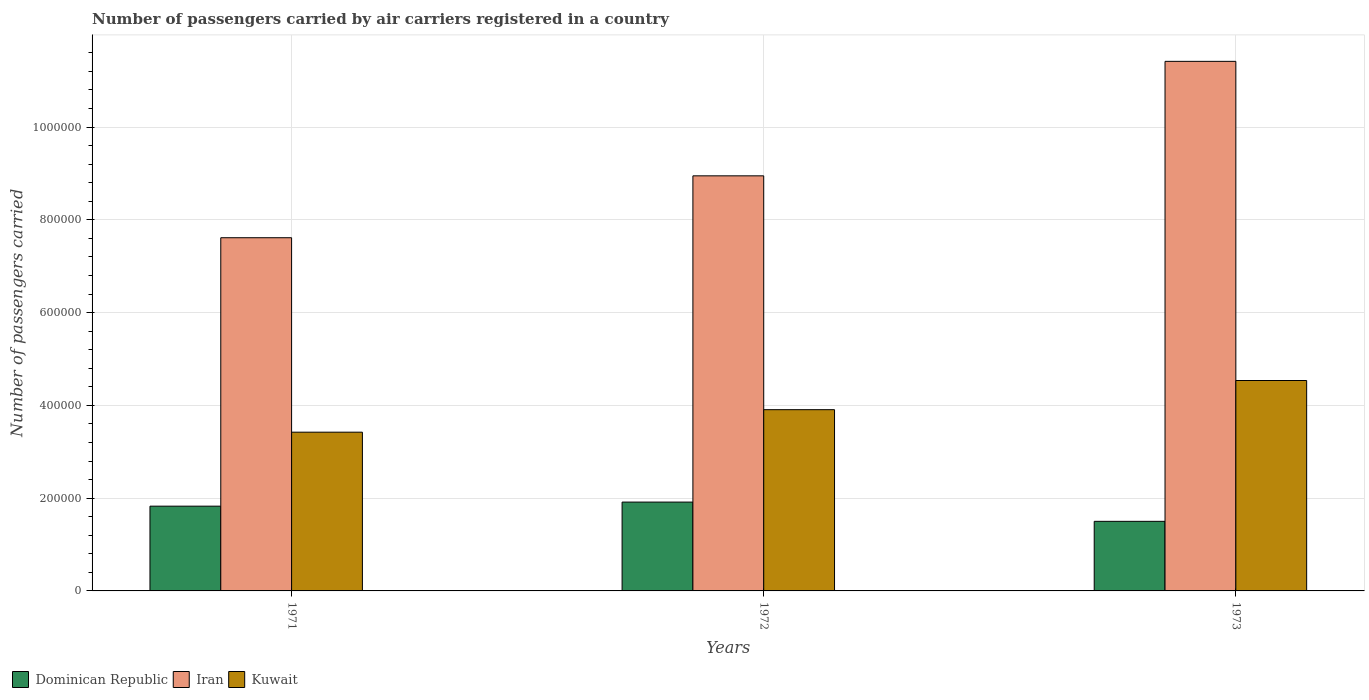How many bars are there on the 2nd tick from the left?
Your answer should be very brief. 3. How many bars are there on the 2nd tick from the right?
Provide a short and direct response. 3. What is the label of the 2nd group of bars from the left?
Give a very brief answer. 1972. In how many cases, is the number of bars for a given year not equal to the number of legend labels?
Give a very brief answer. 0. What is the number of passengers carried by air carriers in Iran in 1971?
Your response must be concise. 7.61e+05. Across all years, what is the maximum number of passengers carried by air carriers in Kuwait?
Offer a very short reply. 4.54e+05. Across all years, what is the minimum number of passengers carried by air carriers in Kuwait?
Provide a succinct answer. 3.42e+05. In which year was the number of passengers carried by air carriers in Kuwait minimum?
Ensure brevity in your answer.  1971. What is the total number of passengers carried by air carriers in Iran in the graph?
Provide a succinct answer. 2.80e+06. What is the difference between the number of passengers carried by air carriers in Kuwait in 1971 and that in 1973?
Ensure brevity in your answer.  -1.11e+05. What is the difference between the number of passengers carried by air carriers in Iran in 1973 and the number of passengers carried by air carriers in Kuwait in 1972?
Provide a succinct answer. 7.51e+05. What is the average number of passengers carried by air carriers in Iran per year?
Keep it short and to the point. 9.33e+05. In the year 1971, what is the difference between the number of passengers carried by air carriers in Iran and number of passengers carried by air carriers in Dominican Republic?
Ensure brevity in your answer.  5.79e+05. What is the ratio of the number of passengers carried by air carriers in Iran in 1971 to that in 1972?
Provide a short and direct response. 0.85. What is the difference between the highest and the second highest number of passengers carried by air carriers in Kuwait?
Keep it short and to the point. 6.29e+04. What is the difference between the highest and the lowest number of passengers carried by air carriers in Iran?
Your response must be concise. 3.80e+05. In how many years, is the number of passengers carried by air carriers in Kuwait greater than the average number of passengers carried by air carriers in Kuwait taken over all years?
Make the answer very short. 1. Is the sum of the number of passengers carried by air carriers in Iran in 1971 and 1972 greater than the maximum number of passengers carried by air carriers in Kuwait across all years?
Offer a very short reply. Yes. What does the 2nd bar from the left in 1973 represents?
Provide a short and direct response. Iran. What does the 1st bar from the right in 1973 represents?
Keep it short and to the point. Kuwait. How many years are there in the graph?
Provide a succinct answer. 3. Does the graph contain grids?
Your answer should be compact. Yes. Where does the legend appear in the graph?
Make the answer very short. Bottom left. How are the legend labels stacked?
Offer a terse response. Horizontal. What is the title of the graph?
Your answer should be compact. Number of passengers carried by air carriers registered in a country. What is the label or title of the Y-axis?
Your answer should be compact. Number of passengers carried. What is the Number of passengers carried of Dominican Republic in 1971?
Provide a short and direct response. 1.83e+05. What is the Number of passengers carried of Iran in 1971?
Make the answer very short. 7.61e+05. What is the Number of passengers carried in Kuwait in 1971?
Ensure brevity in your answer.  3.42e+05. What is the Number of passengers carried of Dominican Republic in 1972?
Your response must be concise. 1.92e+05. What is the Number of passengers carried in Iran in 1972?
Offer a terse response. 8.95e+05. What is the Number of passengers carried in Kuwait in 1972?
Keep it short and to the point. 3.91e+05. What is the Number of passengers carried in Iran in 1973?
Give a very brief answer. 1.14e+06. What is the Number of passengers carried in Kuwait in 1973?
Ensure brevity in your answer.  4.54e+05. Across all years, what is the maximum Number of passengers carried of Dominican Republic?
Offer a very short reply. 1.92e+05. Across all years, what is the maximum Number of passengers carried of Iran?
Provide a short and direct response. 1.14e+06. Across all years, what is the maximum Number of passengers carried in Kuwait?
Offer a very short reply. 4.54e+05. Across all years, what is the minimum Number of passengers carried in Iran?
Give a very brief answer. 7.61e+05. Across all years, what is the minimum Number of passengers carried of Kuwait?
Your answer should be very brief. 3.42e+05. What is the total Number of passengers carried of Dominican Republic in the graph?
Your response must be concise. 5.24e+05. What is the total Number of passengers carried of Iran in the graph?
Ensure brevity in your answer.  2.80e+06. What is the total Number of passengers carried of Kuwait in the graph?
Ensure brevity in your answer.  1.19e+06. What is the difference between the Number of passengers carried in Dominican Republic in 1971 and that in 1972?
Offer a very short reply. -8800. What is the difference between the Number of passengers carried in Iran in 1971 and that in 1972?
Provide a short and direct response. -1.33e+05. What is the difference between the Number of passengers carried in Kuwait in 1971 and that in 1972?
Provide a succinct answer. -4.85e+04. What is the difference between the Number of passengers carried of Dominican Republic in 1971 and that in 1973?
Provide a succinct answer. 3.27e+04. What is the difference between the Number of passengers carried in Iran in 1971 and that in 1973?
Provide a succinct answer. -3.80e+05. What is the difference between the Number of passengers carried in Kuwait in 1971 and that in 1973?
Provide a short and direct response. -1.11e+05. What is the difference between the Number of passengers carried in Dominican Republic in 1972 and that in 1973?
Your answer should be compact. 4.15e+04. What is the difference between the Number of passengers carried of Iran in 1972 and that in 1973?
Your answer should be very brief. -2.47e+05. What is the difference between the Number of passengers carried in Kuwait in 1972 and that in 1973?
Your answer should be very brief. -6.29e+04. What is the difference between the Number of passengers carried of Dominican Republic in 1971 and the Number of passengers carried of Iran in 1972?
Your response must be concise. -7.12e+05. What is the difference between the Number of passengers carried of Dominican Republic in 1971 and the Number of passengers carried of Kuwait in 1972?
Provide a short and direct response. -2.08e+05. What is the difference between the Number of passengers carried of Iran in 1971 and the Number of passengers carried of Kuwait in 1972?
Your answer should be very brief. 3.71e+05. What is the difference between the Number of passengers carried of Dominican Republic in 1971 and the Number of passengers carried of Iran in 1973?
Offer a very short reply. -9.59e+05. What is the difference between the Number of passengers carried in Dominican Republic in 1971 and the Number of passengers carried in Kuwait in 1973?
Offer a terse response. -2.71e+05. What is the difference between the Number of passengers carried of Iran in 1971 and the Number of passengers carried of Kuwait in 1973?
Your answer should be very brief. 3.08e+05. What is the difference between the Number of passengers carried of Dominican Republic in 1972 and the Number of passengers carried of Iran in 1973?
Make the answer very short. -9.50e+05. What is the difference between the Number of passengers carried in Dominican Republic in 1972 and the Number of passengers carried in Kuwait in 1973?
Your response must be concise. -2.62e+05. What is the difference between the Number of passengers carried in Iran in 1972 and the Number of passengers carried in Kuwait in 1973?
Provide a short and direct response. 4.41e+05. What is the average Number of passengers carried in Dominican Republic per year?
Give a very brief answer. 1.75e+05. What is the average Number of passengers carried in Iran per year?
Provide a succinct answer. 9.33e+05. What is the average Number of passengers carried of Kuwait per year?
Your response must be concise. 3.96e+05. In the year 1971, what is the difference between the Number of passengers carried of Dominican Republic and Number of passengers carried of Iran?
Offer a terse response. -5.79e+05. In the year 1971, what is the difference between the Number of passengers carried of Dominican Republic and Number of passengers carried of Kuwait?
Keep it short and to the point. -1.60e+05. In the year 1971, what is the difference between the Number of passengers carried of Iran and Number of passengers carried of Kuwait?
Your answer should be compact. 4.19e+05. In the year 1972, what is the difference between the Number of passengers carried in Dominican Republic and Number of passengers carried in Iran?
Your answer should be very brief. -7.03e+05. In the year 1972, what is the difference between the Number of passengers carried in Dominican Republic and Number of passengers carried in Kuwait?
Keep it short and to the point. -1.99e+05. In the year 1972, what is the difference between the Number of passengers carried of Iran and Number of passengers carried of Kuwait?
Offer a terse response. 5.04e+05. In the year 1973, what is the difference between the Number of passengers carried of Dominican Republic and Number of passengers carried of Iran?
Your answer should be very brief. -9.92e+05. In the year 1973, what is the difference between the Number of passengers carried in Dominican Republic and Number of passengers carried in Kuwait?
Make the answer very short. -3.04e+05. In the year 1973, what is the difference between the Number of passengers carried of Iran and Number of passengers carried of Kuwait?
Offer a very short reply. 6.88e+05. What is the ratio of the Number of passengers carried of Dominican Republic in 1971 to that in 1972?
Keep it short and to the point. 0.95. What is the ratio of the Number of passengers carried in Iran in 1971 to that in 1972?
Keep it short and to the point. 0.85. What is the ratio of the Number of passengers carried of Kuwait in 1971 to that in 1972?
Make the answer very short. 0.88. What is the ratio of the Number of passengers carried in Dominican Republic in 1971 to that in 1973?
Your answer should be compact. 1.22. What is the ratio of the Number of passengers carried in Iran in 1971 to that in 1973?
Give a very brief answer. 0.67. What is the ratio of the Number of passengers carried of Kuwait in 1971 to that in 1973?
Provide a short and direct response. 0.75. What is the ratio of the Number of passengers carried of Dominican Republic in 1972 to that in 1973?
Keep it short and to the point. 1.28. What is the ratio of the Number of passengers carried of Iran in 1972 to that in 1973?
Your answer should be very brief. 0.78. What is the ratio of the Number of passengers carried in Kuwait in 1972 to that in 1973?
Give a very brief answer. 0.86. What is the difference between the highest and the second highest Number of passengers carried of Dominican Republic?
Make the answer very short. 8800. What is the difference between the highest and the second highest Number of passengers carried of Iran?
Keep it short and to the point. 2.47e+05. What is the difference between the highest and the second highest Number of passengers carried of Kuwait?
Ensure brevity in your answer.  6.29e+04. What is the difference between the highest and the lowest Number of passengers carried in Dominican Republic?
Make the answer very short. 4.15e+04. What is the difference between the highest and the lowest Number of passengers carried of Iran?
Make the answer very short. 3.80e+05. What is the difference between the highest and the lowest Number of passengers carried in Kuwait?
Ensure brevity in your answer.  1.11e+05. 